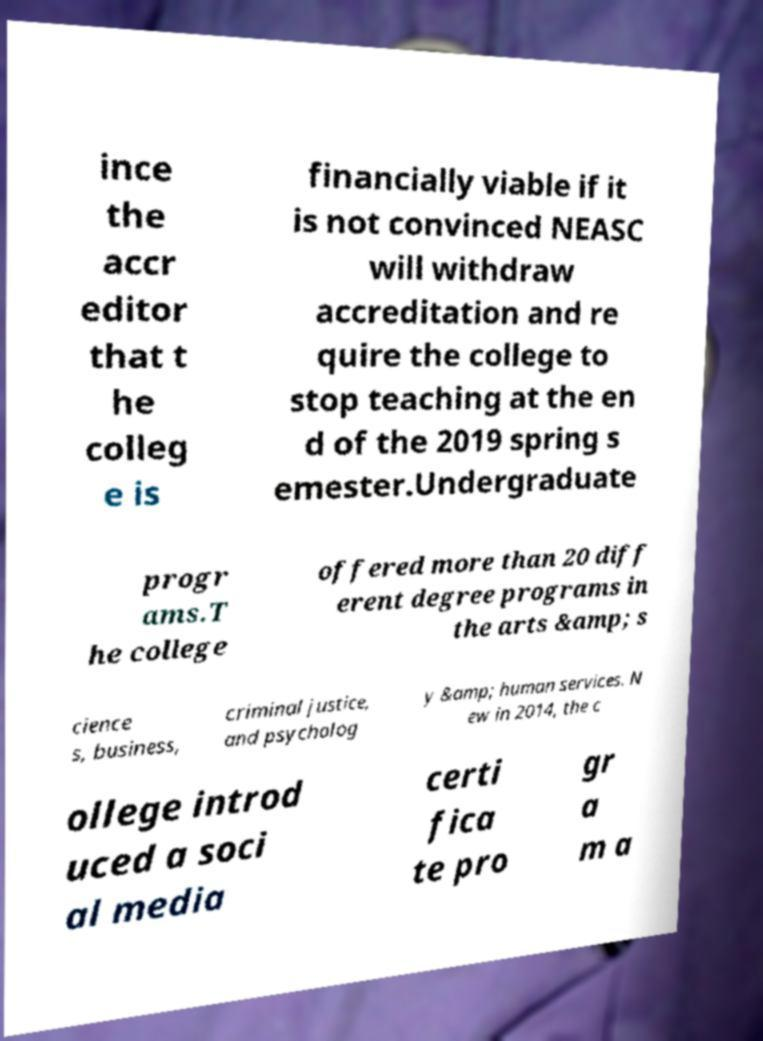Can you read and provide the text displayed in the image?This photo seems to have some interesting text. Can you extract and type it out for me? ince the accr editor that t he colleg e is financially viable if it is not convinced NEASC will withdraw accreditation and re quire the college to stop teaching at the en d of the 2019 spring s emester.Undergraduate progr ams.T he college offered more than 20 diff erent degree programs in the arts &amp; s cience s, business, criminal justice, and psycholog y &amp; human services. N ew in 2014, the c ollege introd uced a soci al media certi fica te pro gr a m a 